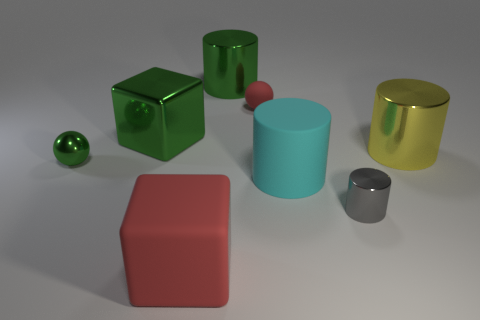Subtract all green cylinders. How many cylinders are left? 3 Add 2 tiny green metal blocks. How many objects exist? 10 Subtract 1 spheres. How many spheres are left? 1 Subtract all gray cylinders. How many cylinders are left? 3 Add 1 red things. How many red things are left? 3 Add 6 tiny purple shiny cylinders. How many tiny purple shiny cylinders exist? 6 Subtract 0 purple cylinders. How many objects are left? 8 Subtract all spheres. How many objects are left? 6 Subtract all gray cylinders. Subtract all green cubes. How many cylinders are left? 3 Subtract all tiny gray metal spheres. Subtract all green metal cylinders. How many objects are left? 7 